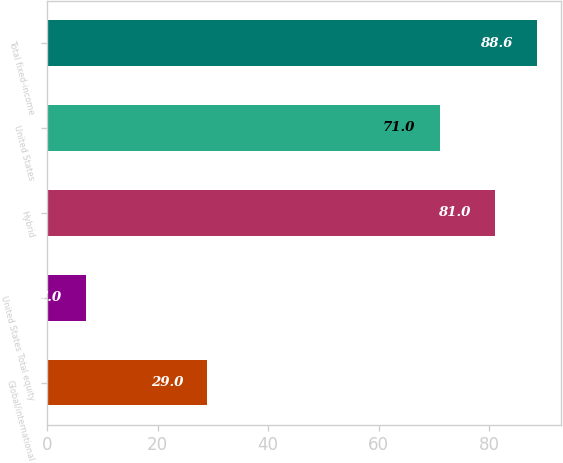<chart> <loc_0><loc_0><loc_500><loc_500><bar_chart><fcel>Global/international<fcel>United States Total equity<fcel>Hybrid<fcel>United States<fcel>Total fixed-income<nl><fcel>29<fcel>7<fcel>81<fcel>71<fcel>88.6<nl></chart> 